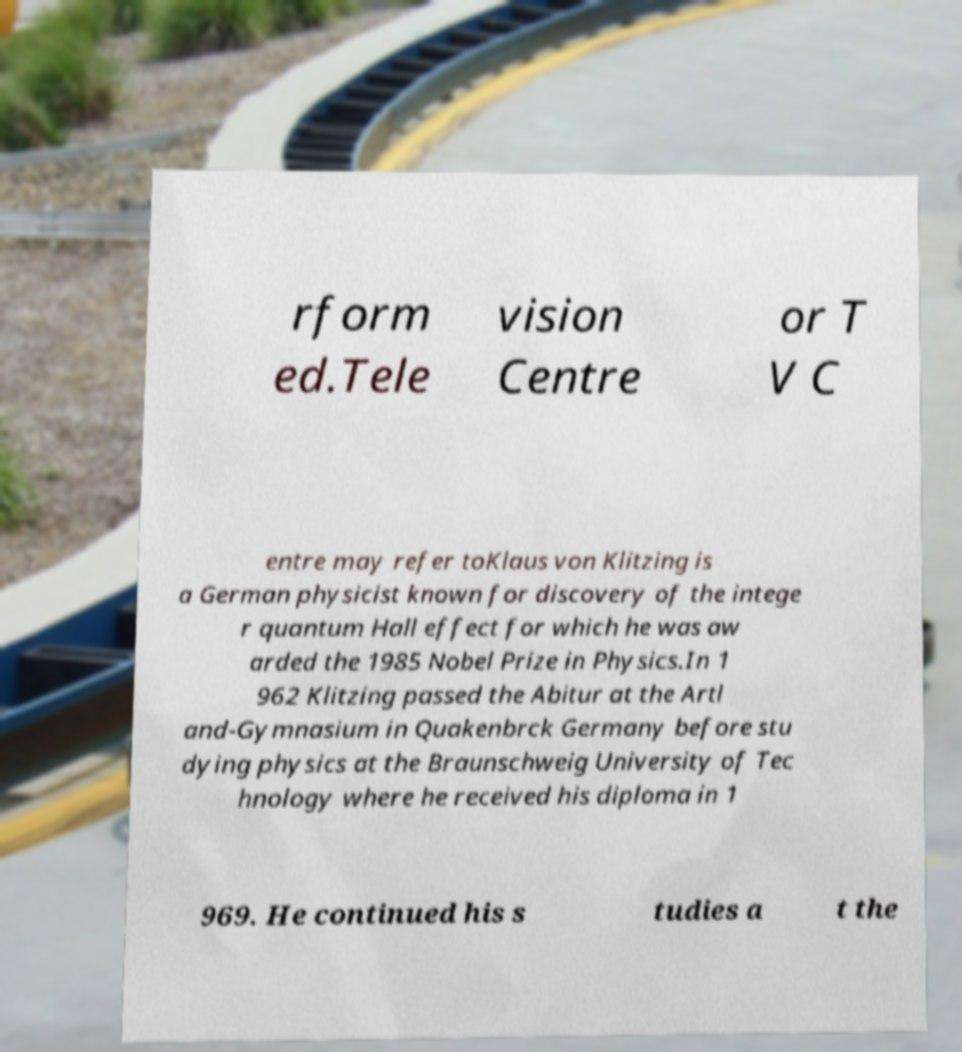Can you accurately transcribe the text from the provided image for me? rform ed.Tele vision Centre or T V C entre may refer toKlaus von Klitzing is a German physicist known for discovery of the intege r quantum Hall effect for which he was aw arded the 1985 Nobel Prize in Physics.In 1 962 Klitzing passed the Abitur at the Artl and-Gymnasium in Quakenbrck Germany before stu dying physics at the Braunschweig University of Tec hnology where he received his diploma in 1 969. He continued his s tudies a t the 